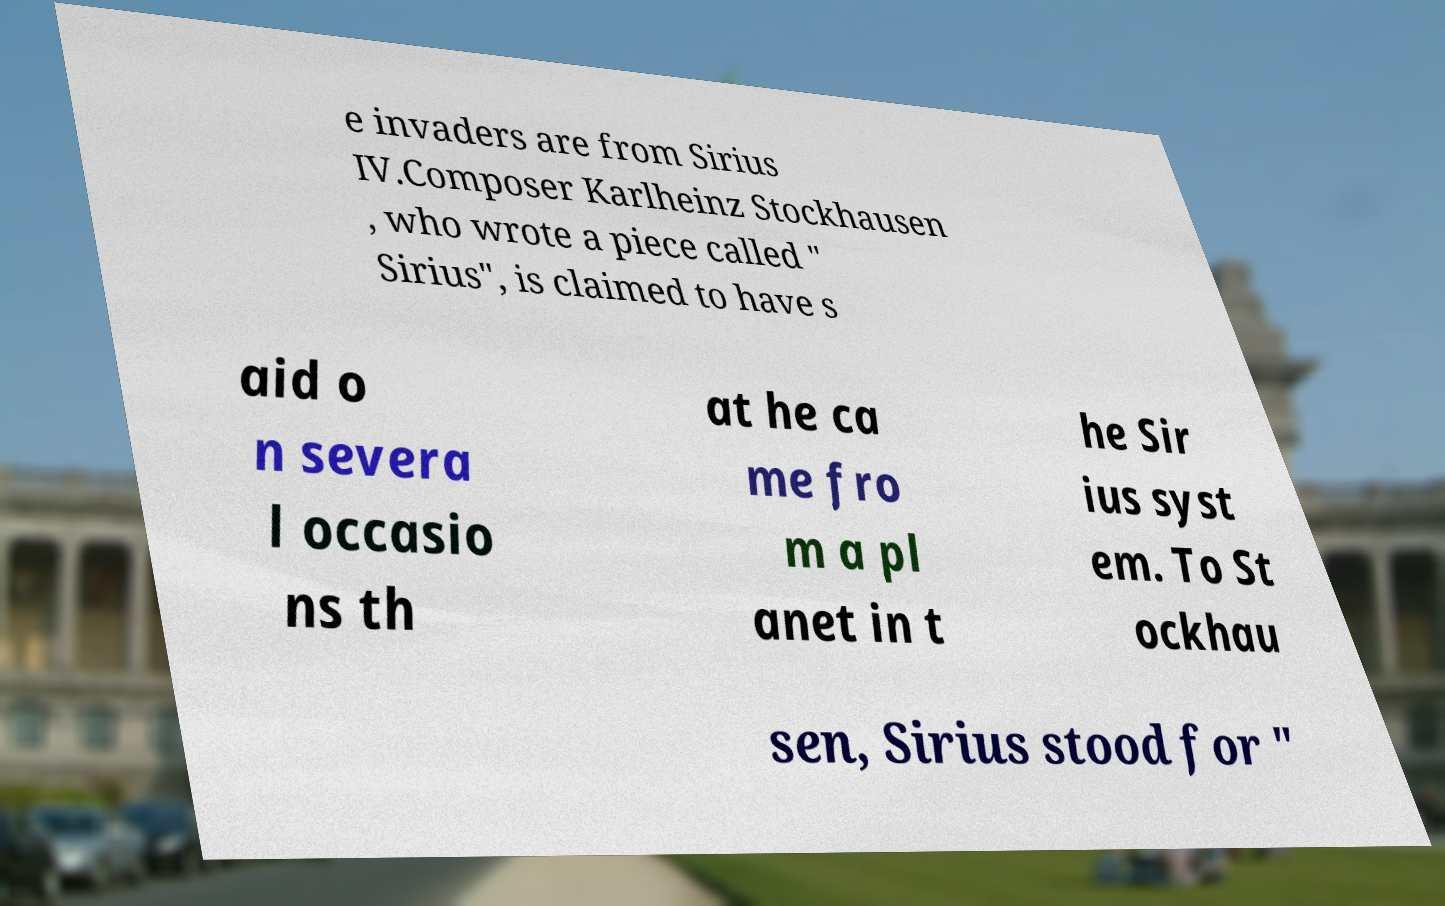What messages or text are displayed in this image? I need them in a readable, typed format. e invaders are from Sirius IV.Composer Karlheinz Stockhausen , who wrote a piece called " Sirius", is claimed to have s aid o n severa l occasio ns th at he ca me fro m a pl anet in t he Sir ius syst em. To St ockhau sen, Sirius stood for " 